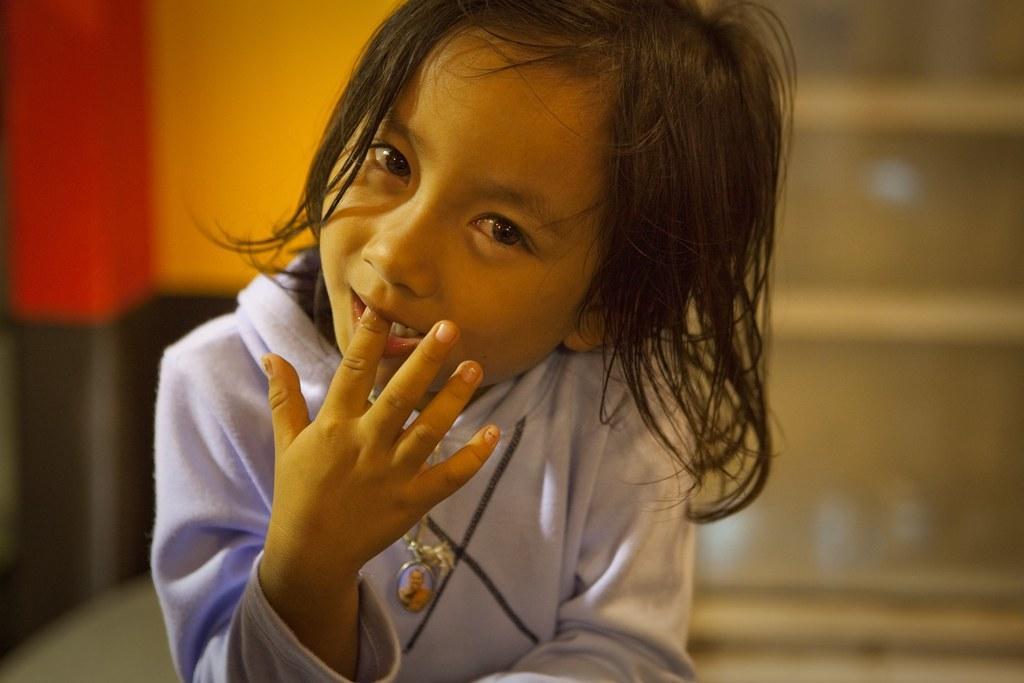Can you describe this image briefly? In this image I can see the person and I can see the blurred background. 